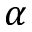<formula> <loc_0><loc_0><loc_500><loc_500>\alpha</formula> 